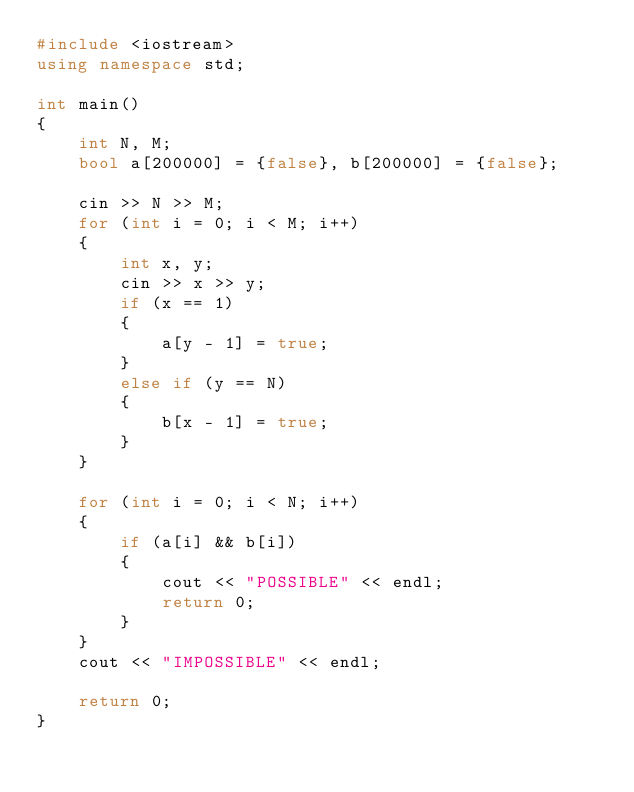Convert code to text. <code><loc_0><loc_0><loc_500><loc_500><_C++_>#include <iostream>
using namespace std;

int main()
{
    int N, M;
    bool a[200000] = {false}, b[200000] = {false};

    cin >> N >> M;
    for (int i = 0; i < M; i++)
    {
        int x, y;
        cin >> x >> y;
        if (x == 1)
        {
            a[y - 1] = true;
        }
        else if (y == N)
        {
            b[x - 1] = true;
        }
    }

    for (int i = 0; i < N; i++)
    {
        if (a[i] && b[i])
        {
            cout << "POSSIBLE" << endl;
            return 0;
        }
    }
    cout << "IMPOSSIBLE" << endl;

    return 0;
}</code> 